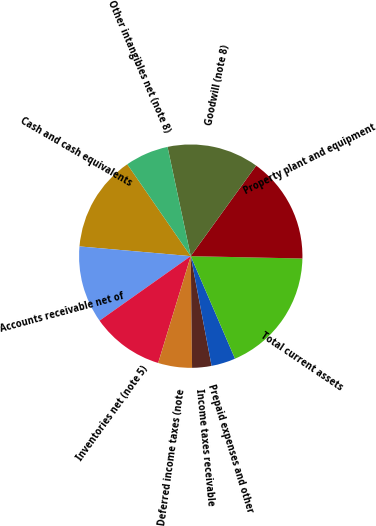<chart> <loc_0><loc_0><loc_500><loc_500><pie_chart><fcel>Cash and cash equivalents<fcel>Accounts receivable net of<fcel>Inventories net (note 5)<fcel>Deferred income taxes (note<fcel>Income taxes receivable<fcel>Prepaid expenses and other<fcel>Total current assets<fcel>Property plant and equipment<fcel>Goodwill (note 8)<fcel>Other intangibles net (note 8)<nl><fcel>13.99%<fcel>11.19%<fcel>10.49%<fcel>4.9%<fcel>2.8%<fcel>3.5%<fcel>18.18%<fcel>15.38%<fcel>13.29%<fcel>6.29%<nl></chart> 